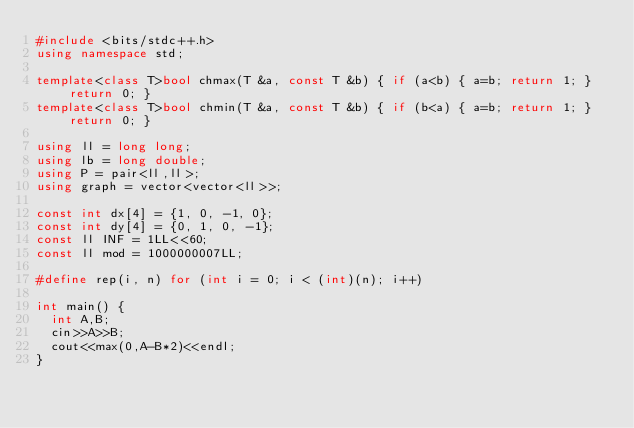Convert code to text. <code><loc_0><loc_0><loc_500><loc_500><_C++_>#include <bits/stdc++.h>
using namespace std;

template<class T>bool chmax(T &a, const T &b) { if (a<b) { a=b; return 1; } return 0; }
template<class T>bool chmin(T &a, const T &b) { if (b<a) { a=b; return 1; } return 0; }

using ll = long long;
using lb = long double;
using P = pair<ll,ll>;
using graph = vector<vector<ll>>;

const int dx[4] = {1, 0, -1, 0};
const int dy[4] = {0, 1, 0, -1};
const ll INF = 1LL<<60;
const ll mod = 1000000007LL;

#define rep(i, n) for (int i = 0; i < (int)(n); i++)

int main() {
  int A,B;
  cin>>A>>B;
  cout<<max(0,A-B*2)<<endl;
}</code> 